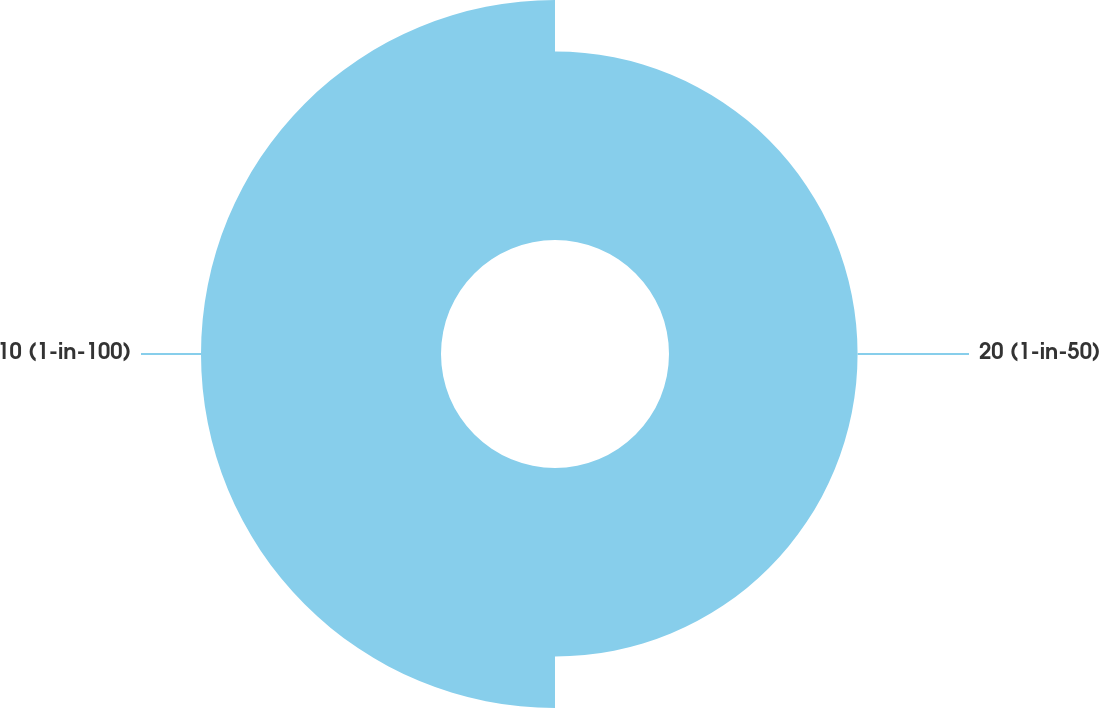<chart> <loc_0><loc_0><loc_500><loc_500><pie_chart><fcel>20 (1-in-50)<fcel>10 (1-in-100)<nl><fcel>44.0%<fcel>56.0%<nl></chart> 